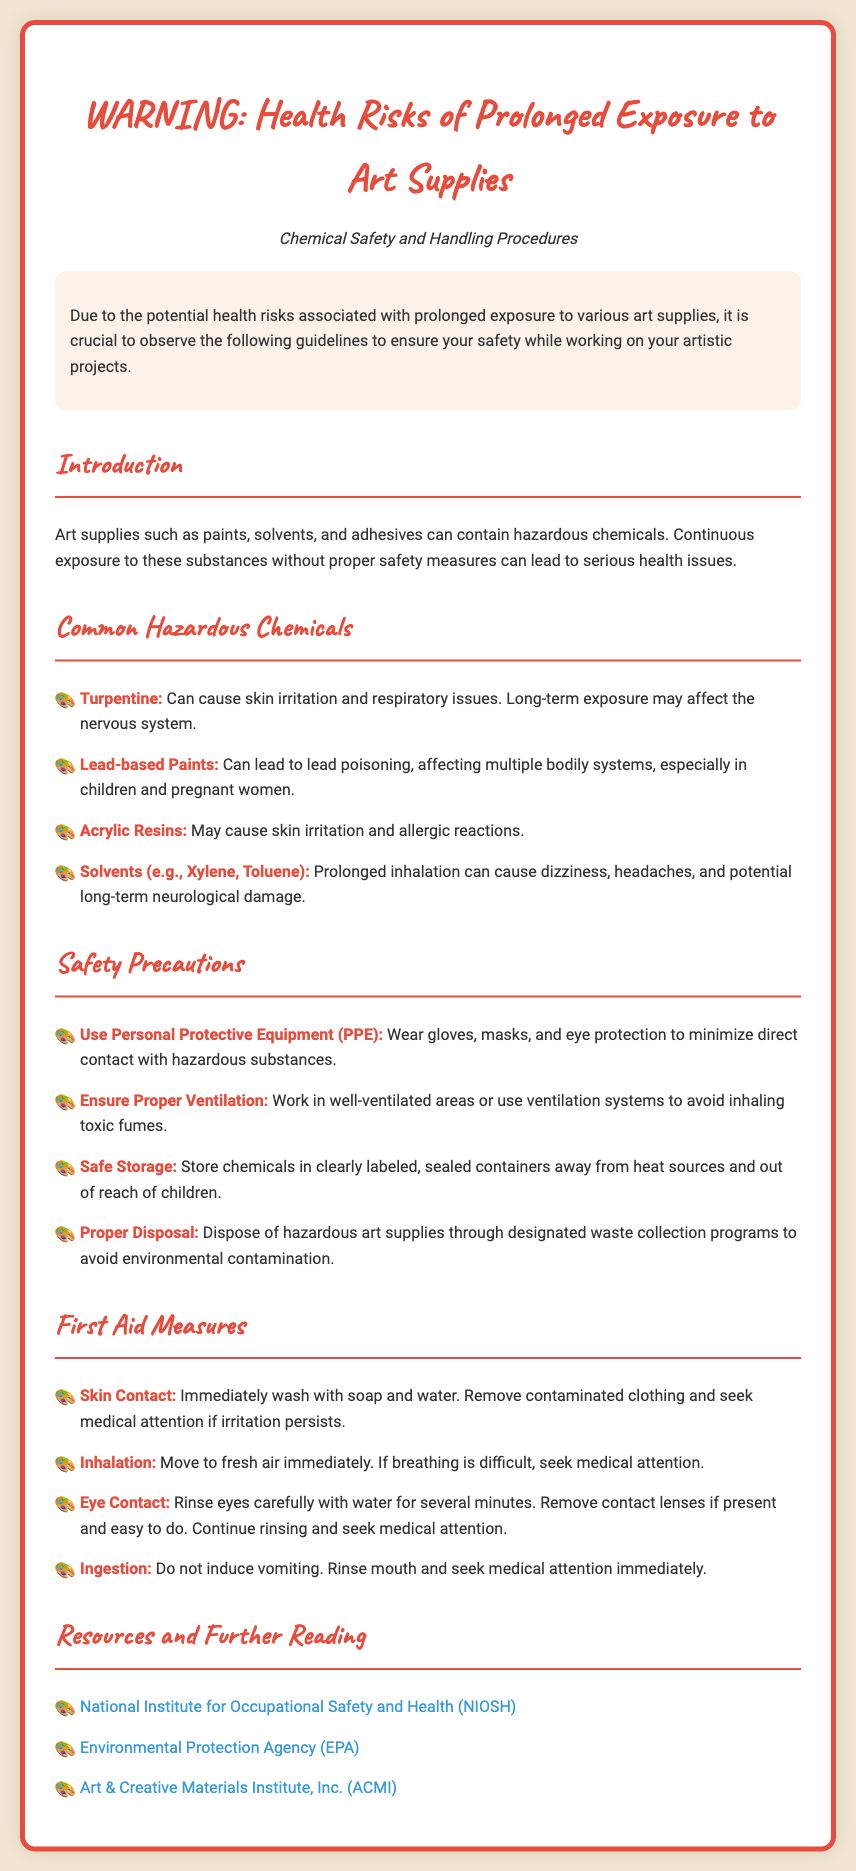What are the health risks associated with prolonged exposure to art supplies? The document mentions that continuous exposure can lead to serious health issues.
Answer: Serious health issues What are two common hazardous chemicals listed? The document specifies three examples: Turpentine and Lead-based Paints as common hazardous chemicals.
Answer: Turpentine, Lead-based Paints Which PPE should be used while handling hazardous substances? The document specifically states that gloves, masks, and eye protection should be worn.
Answer: Gloves, masks, eye protection What should be done in case of skin contact with toxic art materials? The document instructs immediate washing with soap and water and seeking medical attention if irritation persists.
Answer: Wash with soap and water What organization is listed for further reading on occupational safety? The document provides multiple resources, one of which is the National Institute for Occupational Safety and Health (NIOSH).
Answer: National Institute for Occupational Safety and Health (NIOSH) Which chemicals may cause respiratory issues? The document specifically highlights Turpentine and various solvents as having the potential for respiratory issues.
Answer: Turpentine, solvents What should be done in case of ingestion of hazardous materials? The document instructs not to induce vomiting and to seek medical attention immediately.
Answer: Seek medical attention immediately What is advised for the ventilation while working with art supplies? The document states that it's important to work in well-ventilated areas or use ventilation systems.
Answer: Well-ventilated areas How should hazardous art supplies be stored? The document emphasizes that chemicals should be stored in clearly labeled, sealed containers.
Answer: Clearly labeled, sealed containers 